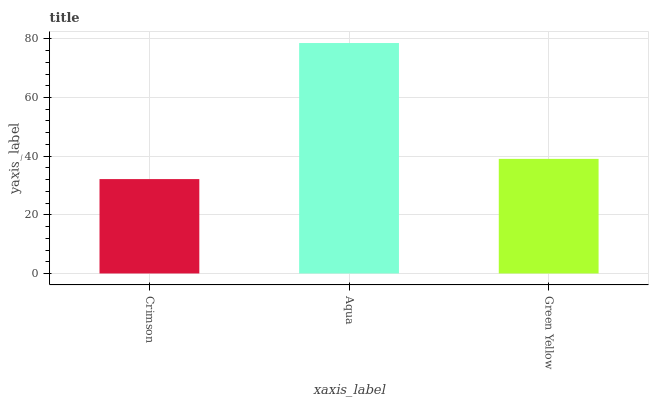Is Crimson the minimum?
Answer yes or no. Yes. Is Aqua the maximum?
Answer yes or no. Yes. Is Green Yellow the minimum?
Answer yes or no. No. Is Green Yellow the maximum?
Answer yes or no. No. Is Aqua greater than Green Yellow?
Answer yes or no. Yes. Is Green Yellow less than Aqua?
Answer yes or no. Yes. Is Green Yellow greater than Aqua?
Answer yes or no. No. Is Aqua less than Green Yellow?
Answer yes or no. No. Is Green Yellow the high median?
Answer yes or no. Yes. Is Green Yellow the low median?
Answer yes or no. Yes. Is Aqua the high median?
Answer yes or no. No. Is Aqua the low median?
Answer yes or no. No. 